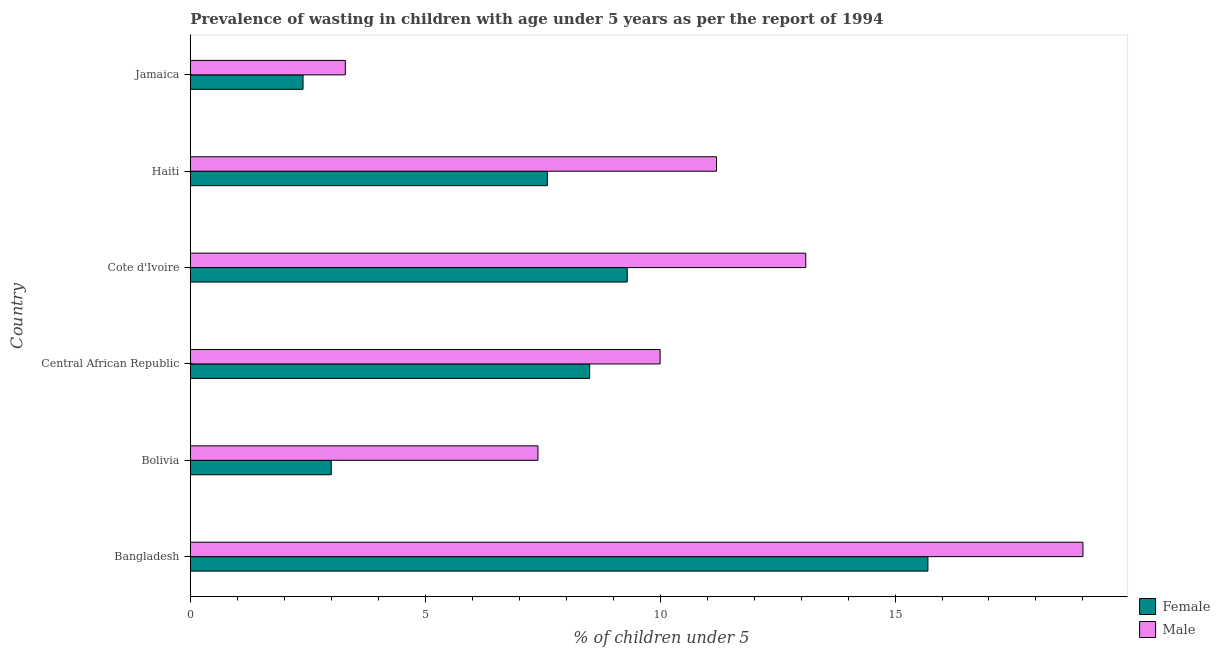How many groups of bars are there?
Provide a short and direct response. 6. How many bars are there on the 5th tick from the top?
Provide a short and direct response. 2. What is the label of the 4th group of bars from the top?
Ensure brevity in your answer.  Central African Republic. What is the percentage of undernourished male children in Jamaica?
Offer a very short reply. 3.3. Across all countries, what is the maximum percentage of undernourished female children?
Make the answer very short. 15.7. Across all countries, what is the minimum percentage of undernourished male children?
Provide a succinct answer. 3.3. In which country was the percentage of undernourished female children maximum?
Offer a very short reply. Bangladesh. In which country was the percentage of undernourished male children minimum?
Make the answer very short. Jamaica. What is the total percentage of undernourished male children in the graph?
Provide a short and direct response. 64. What is the difference between the percentage of undernourished female children in Central African Republic and the percentage of undernourished male children in Cote d'Ivoire?
Your response must be concise. -4.6. What is the average percentage of undernourished male children per country?
Your answer should be very brief. 10.67. What is the difference between the percentage of undernourished female children and percentage of undernourished male children in Central African Republic?
Offer a very short reply. -1.5. What is the ratio of the percentage of undernourished female children in Central African Republic to that in Jamaica?
Provide a short and direct response. 3.54. Is the percentage of undernourished male children in Bangladesh less than that in Central African Republic?
Your response must be concise. No. Is the difference between the percentage of undernourished male children in Bangladesh and Central African Republic greater than the difference between the percentage of undernourished female children in Bangladesh and Central African Republic?
Offer a very short reply. Yes. In how many countries, is the percentage of undernourished female children greater than the average percentage of undernourished female children taken over all countries?
Your answer should be very brief. 3. Is the sum of the percentage of undernourished female children in Bolivia and Haiti greater than the maximum percentage of undernourished male children across all countries?
Make the answer very short. No. How many bars are there?
Give a very brief answer. 12. Are all the bars in the graph horizontal?
Your answer should be very brief. Yes. Does the graph contain any zero values?
Provide a succinct answer. No. What is the title of the graph?
Provide a short and direct response. Prevalence of wasting in children with age under 5 years as per the report of 1994. Does "Goods and services" appear as one of the legend labels in the graph?
Give a very brief answer. No. What is the label or title of the X-axis?
Offer a very short reply.  % of children under 5. What is the  % of children under 5 of Female in Bangladesh?
Make the answer very short. 15.7. What is the  % of children under 5 in Male in Bangladesh?
Make the answer very short. 19. What is the  % of children under 5 of Female in Bolivia?
Your answer should be very brief. 3. What is the  % of children under 5 in Male in Bolivia?
Keep it short and to the point. 7.4. What is the  % of children under 5 of Female in Central African Republic?
Offer a very short reply. 8.5. What is the  % of children under 5 of Male in Central African Republic?
Keep it short and to the point. 10. What is the  % of children under 5 in Female in Cote d'Ivoire?
Provide a succinct answer. 9.3. What is the  % of children under 5 in Male in Cote d'Ivoire?
Your response must be concise. 13.1. What is the  % of children under 5 of Female in Haiti?
Your answer should be very brief. 7.6. What is the  % of children under 5 in Male in Haiti?
Your answer should be compact. 11.2. What is the  % of children under 5 in Female in Jamaica?
Provide a succinct answer. 2.4. What is the  % of children under 5 in Male in Jamaica?
Offer a very short reply. 3.3. Across all countries, what is the maximum  % of children under 5 of Female?
Give a very brief answer. 15.7. Across all countries, what is the maximum  % of children under 5 of Male?
Give a very brief answer. 19. Across all countries, what is the minimum  % of children under 5 in Female?
Provide a short and direct response. 2.4. Across all countries, what is the minimum  % of children under 5 in Male?
Make the answer very short. 3.3. What is the total  % of children under 5 in Female in the graph?
Provide a succinct answer. 46.5. What is the total  % of children under 5 of Male in the graph?
Your answer should be compact. 64. What is the difference between the  % of children under 5 in Female in Bangladesh and that in Bolivia?
Your answer should be compact. 12.7. What is the difference between the  % of children under 5 in Female in Bangladesh and that in Central African Republic?
Ensure brevity in your answer.  7.2. What is the difference between the  % of children under 5 in Male in Bangladesh and that in Central African Republic?
Keep it short and to the point. 9. What is the difference between the  % of children under 5 in Female in Bangladesh and that in Cote d'Ivoire?
Your response must be concise. 6.4. What is the difference between the  % of children under 5 in Male in Bangladesh and that in Cote d'Ivoire?
Offer a terse response. 5.9. What is the difference between the  % of children under 5 in Female in Bangladesh and that in Haiti?
Provide a short and direct response. 8.1. What is the difference between the  % of children under 5 of Male in Bangladesh and that in Haiti?
Your answer should be compact. 7.8. What is the difference between the  % of children under 5 of Female in Bolivia and that in Central African Republic?
Your answer should be compact. -5.5. What is the difference between the  % of children under 5 of Female in Bolivia and that in Cote d'Ivoire?
Give a very brief answer. -6.3. What is the difference between the  % of children under 5 of Male in Bolivia and that in Cote d'Ivoire?
Your answer should be very brief. -5.7. What is the difference between the  % of children under 5 of Female in Central African Republic and that in Cote d'Ivoire?
Make the answer very short. -0.8. What is the difference between the  % of children under 5 of Male in Central African Republic and that in Cote d'Ivoire?
Offer a very short reply. -3.1. What is the difference between the  % of children under 5 of Female in Central African Republic and that in Haiti?
Provide a succinct answer. 0.9. What is the difference between the  % of children under 5 in Male in Central African Republic and that in Haiti?
Keep it short and to the point. -1.2. What is the difference between the  % of children under 5 in Female in Cote d'Ivoire and that in Haiti?
Provide a short and direct response. 1.7. What is the difference between the  % of children under 5 of Female in Cote d'Ivoire and that in Jamaica?
Offer a very short reply. 6.9. What is the difference between the  % of children under 5 of Male in Cote d'Ivoire and that in Jamaica?
Give a very brief answer. 9.8. What is the difference between the  % of children under 5 in Female in Haiti and that in Jamaica?
Your response must be concise. 5.2. What is the difference between the  % of children under 5 of Female in Bangladesh and the  % of children under 5 of Male in Central African Republic?
Give a very brief answer. 5.7. What is the difference between the  % of children under 5 of Female in Cote d'Ivoire and the  % of children under 5 of Male in Haiti?
Make the answer very short. -1.9. What is the difference between the  % of children under 5 in Female in Haiti and the  % of children under 5 in Male in Jamaica?
Your answer should be compact. 4.3. What is the average  % of children under 5 of Female per country?
Your answer should be very brief. 7.75. What is the average  % of children under 5 of Male per country?
Keep it short and to the point. 10.67. What is the difference between the  % of children under 5 in Female and  % of children under 5 in Male in Central African Republic?
Offer a terse response. -1.5. What is the difference between the  % of children under 5 in Female and  % of children under 5 in Male in Haiti?
Your response must be concise. -3.6. What is the ratio of the  % of children under 5 in Female in Bangladesh to that in Bolivia?
Your answer should be compact. 5.23. What is the ratio of the  % of children under 5 in Male in Bangladesh to that in Bolivia?
Keep it short and to the point. 2.57. What is the ratio of the  % of children under 5 in Female in Bangladesh to that in Central African Republic?
Make the answer very short. 1.85. What is the ratio of the  % of children under 5 of Male in Bangladesh to that in Central African Republic?
Offer a terse response. 1.9. What is the ratio of the  % of children under 5 of Female in Bangladesh to that in Cote d'Ivoire?
Make the answer very short. 1.69. What is the ratio of the  % of children under 5 in Male in Bangladesh to that in Cote d'Ivoire?
Your answer should be very brief. 1.45. What is the ratio of the  % of children under 5 in Female in Bangladesh to that in Haiti?
Your answer should be compact. 2.07. What is the ratio of the  % of children under 5 in Male in Bangladesh to that in Haiti?
Offer a very short reply. 1.7. What is the ratio of the  % of children under 5 of Female in Bangladesh to that in Jamaica?
Your answer should be very brief. 6.54. What is the ratio of the  % of children under 5 in Male in Bangladesh to that in Jamaica?
Your answer should be compact. 5.76. What is the ratio of the  % of children under 5 in Female in Bolivia to that in Central African Republic?
Offer a very short reply. 0.35. What is the ratio of the  % of children under 5 in Male in Bolivia to that in Central African Republic?
Your answer should be compact. 0.74. What is the ratio of the  % of children under 5 of Female in Bolivia to that in Cote d'Ivoire?
Give a very brief answer. 0.32. What is the ratio of the  % of children under 5 of Male in Bolivia to that in Cote d'Ivoire?
Your answer should be compact. 0.56. What is the ratio of the  % of children under 5 of Female in Bolivia to that in Haiti?
Keep it short and to the point. 0.39. What is the ratio of the  % of children under 5 of Male in Bolivia to that in Haiti?
Offer a terse response. 0.66. What is the ratio of the  % of children under 5 of Male in Bolivia to that in Jamaica?
Provide a short and direct response. 2.24. What is the ratio of the  % of children under 5 in Female in Central African Republic to that in Cote d'Ivoire?
Offer a terse response. 0.91. What is the ratio of the  % of children under 5 of Male in Central African Republic to that in Cote d'Ivoire?
Offer a very short reply. 0.76. What is the ratio of the  % of children under 5 in Female in Central African Republic to that in Haiti?
Offer a very short reply. 1.12. What is the ratio of the  % of children under 5 of Male in Central African Republic to that in Haiti?
Keep it short and to the point. 0.89. What is the ratio of the  % of children under 5 in Female in Central African Republic to that in Jamaica?
Your answer should be very brief. 3.54. What is the ratio of the  % of children under 5 of Male in Central African Republic to that in Jamaica?
Provide a succinct answer. 3.03. What is the ratio of the  % of children under 5 in Female in Cote d'Ivoire to that in Haiti?
Ensure brevity in your answer.  1.22. What is the ratio of the  % of children under 5 of Male in Cote d'Ivoire to that in Haiti?
Make the answer very short. 1.17. What is the ratio of the  % of children under 5 in Female in Cote d'Ivoire to that in Jamaica?
Provide a succinct answer. 3.88. What is the ratio of the  % of children under 5 in Male in Cote d'Ivoire to that in Jamaica?
Provide a short and direct response. 3.97. What is the ratio of the  % of children under 5 of Female in Haiti to that in Jamaica?
Provide a short and direct response. 3.17. What is the ratio of the  % of children under 5 of Male in Haiti to that in Jamaica?
Ensure brevity in your answer.  3.39. What is the difference between the highest and the lowest  % of children under 5 in Male?
Offer a very short reply. 15.7. 